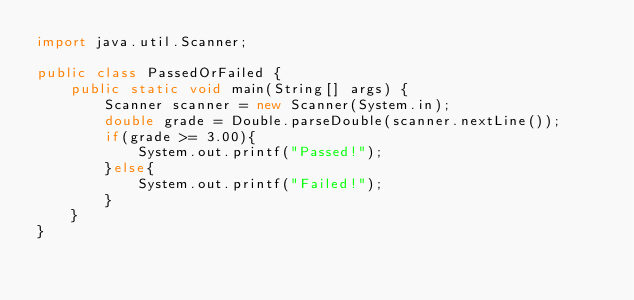Convert code to text. <code><loc_0><loc_0><loc_500><loc_500><_Java_>import java.util.Scanner;

public class PassedOrFailed {
    public static void main(String[] args) {
        Scanner scanner = new Scanner(System.in);
        double grade = Double.parseDouble(scanner.nextLine());
        if(grade >= 3.00){
            System.out.printf("Passed!");
        }else{
            System.out.printf("Failed!");
        }
    }
}</code> 